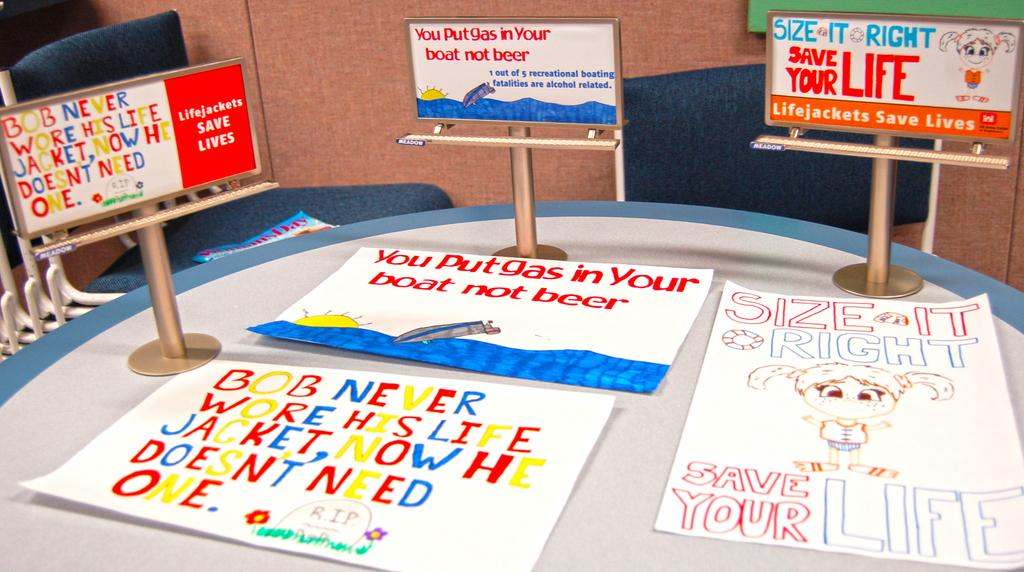What is the main object in the center of the image? There is a table in the center of the image. What is placed on the table? Boards and papers are placed on the table. What can be seen in the background of the image? There are chairs and a wall in the background of the image. What type of car is parked near the table in the image? There is no car present in the image; it only features a table, boards, papers, chairs, and a wall. 